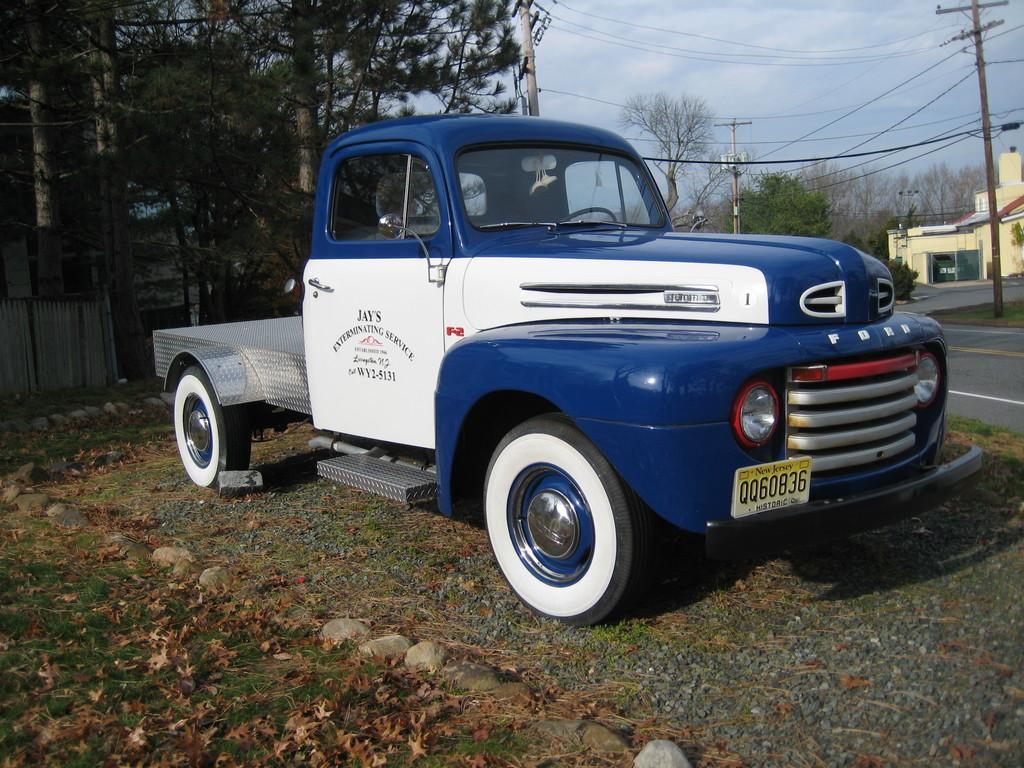Please provide a concise description of this image. In this image there is a vehicle parked, behind the vehicle there are trees and a wooden fence. In the background there are trees, building, few utility poles connected with cables, road and the sky. 